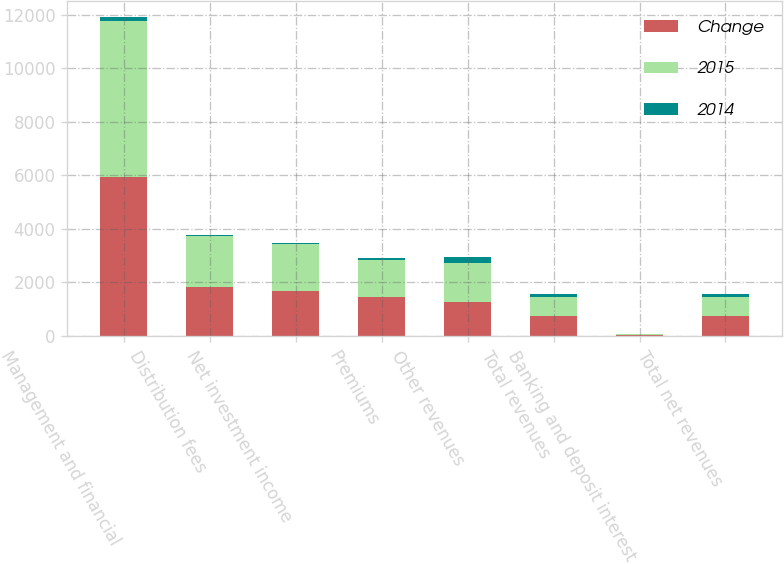Convert chart to OTSL. <chart><loc_0><loc_0><loc_500><loc_500><stacked_bar_chart><ecel><fcel>Management and financial<fcel>Distribution fees<fcel>Net investment income<fcel>Premiums<fcel>Other revenues<fcel>Total revenues<fcel>Banking and deposit interest<fcel>Total net revenues<nl><fcel>Change<fcel>5950<fcel>1847<fcel>1688<fcel>1455<fcel>1260<fcel>733<fcel>30<fcel>733<nl><fcel>2015<fcel>5810<fcel>1894<fcel>1741<fcel>1385<fcel>1466<fcel>733<fcel>28<fcel>733<nl><fcel>2014<fcel>140<fcel>47<fcel>53<fcel>70<fcel>206<fcel>96<fcel>2<fcel>98<nl></chart> 